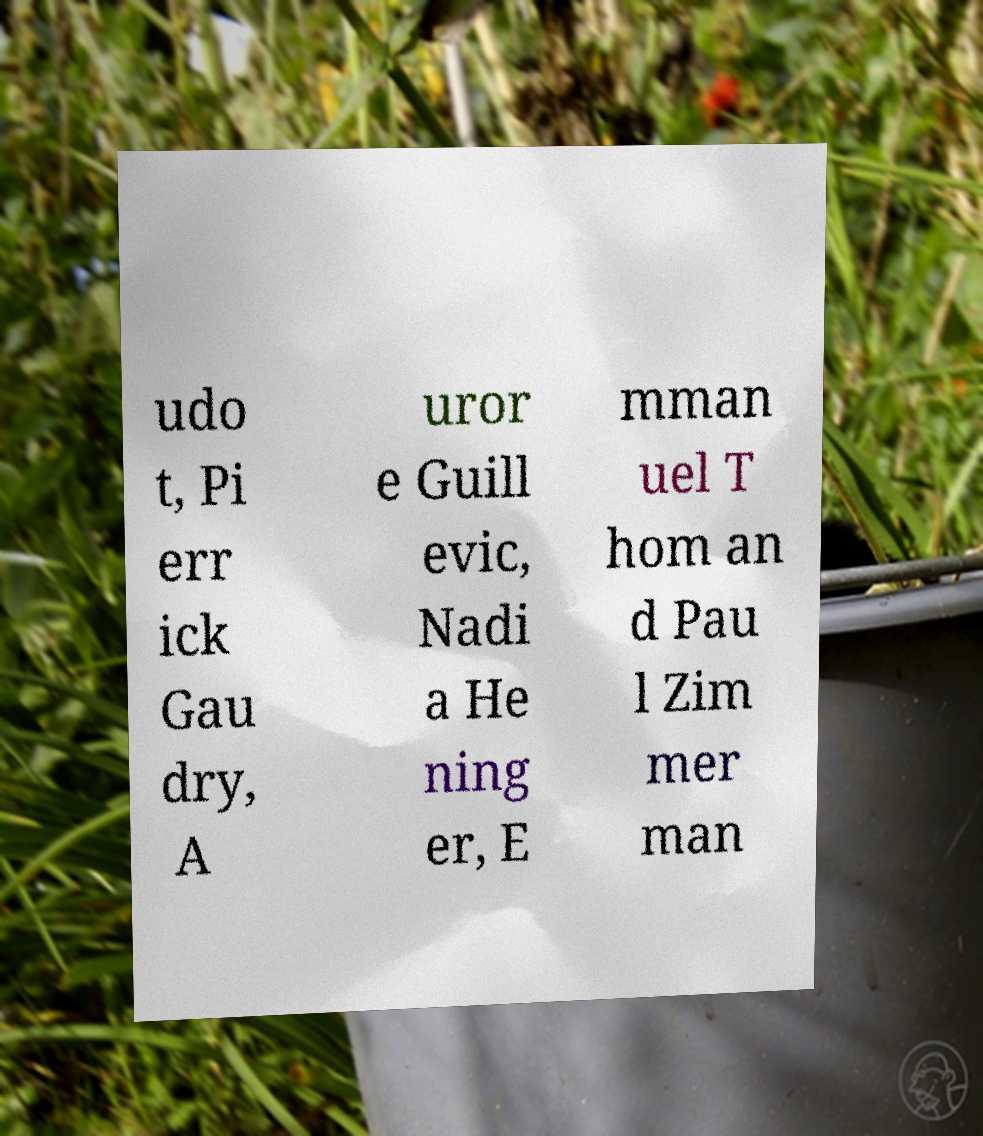Can you accurately transcribe the text from the provided image for me? udo t, Pi err ick Gau dry, A uror e Guill evic, Nadi a He ning er, E mman uel T hom an d Pau l Zim mer man 